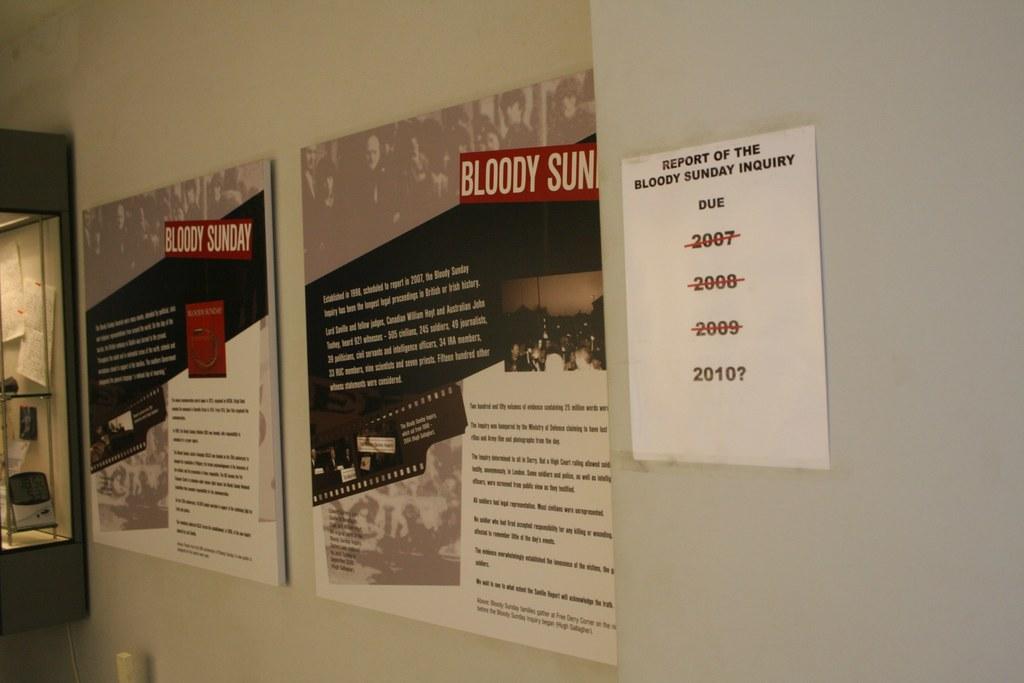What year is the report of the bloody sunday due?
Your response must be concise. 2010. What does the poster say is bloody?
Offer a terse response. Sunday. 